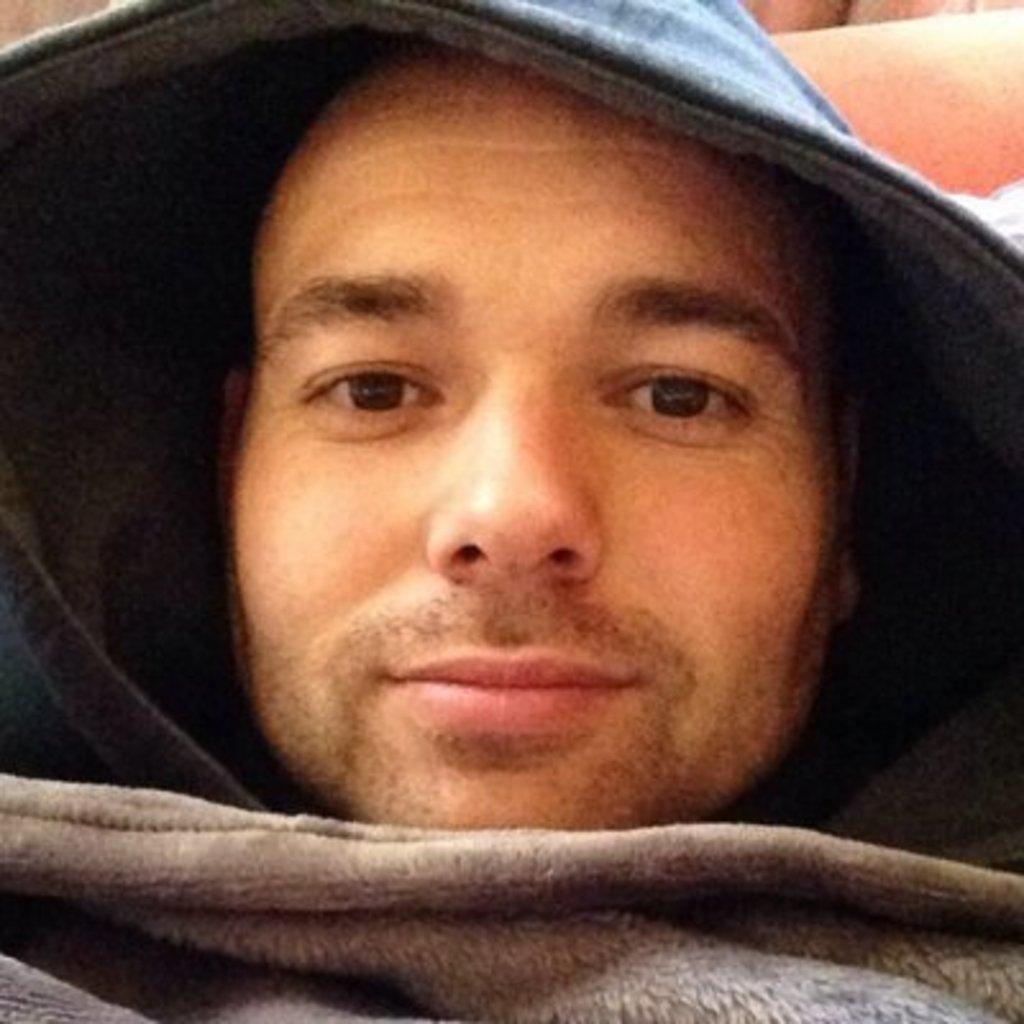In one or two sentences, can you explain what this image depicts? A person is wearing a hoodie and there is a blanket. 